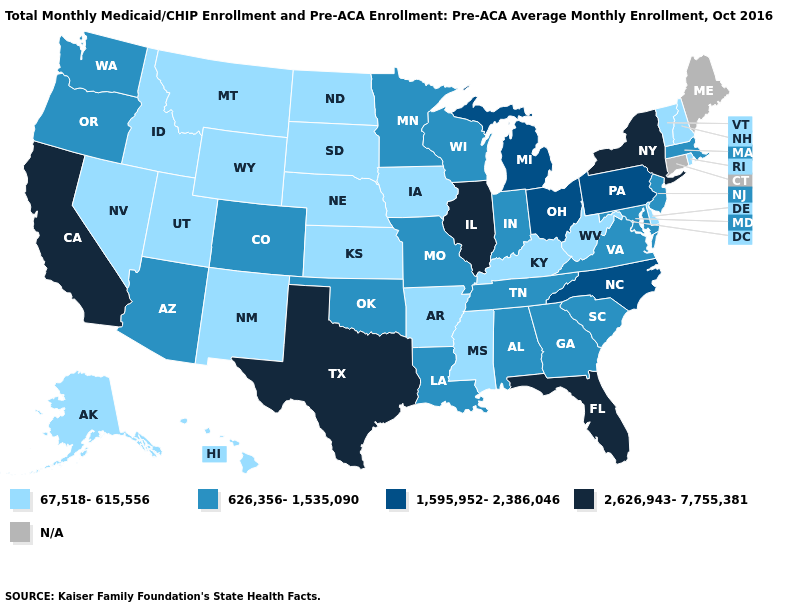What is the value of Colorado?
Concise answer only. 626,356-1,535,090. Does Minnesota have the lowest value in the USA?
Answer briefly. No. Does the first symbol in the legend represent the smallest category?
Short answer required. Yes. What is the value of West Virginia?
Answer briefly. 67,518-615,556. Name the states that have a value in the range N/A?
Be succinct. Connecticut, Maine. How many symbols are there in the legend?
Answer briefly. 5. What is the lowest value in states that border Rhode Island?
Give a very brief answer. 626,356-1,535,090. Does Oregon have the highest value in the West?
Be succinct. No. Name the states that have a value in the range 1,595,952-2,386,046?
Give a very brief answer. Michigan, North Carolina, Ohio, Pennsylvania. Does the first symbol in the legend represent the smallest category?
Short answer required. Yes. Does California have the highest value in the USA?
Quick response, please. Yes. What is the value of Idaho?
Answer briefly. 67,518-615,556. 